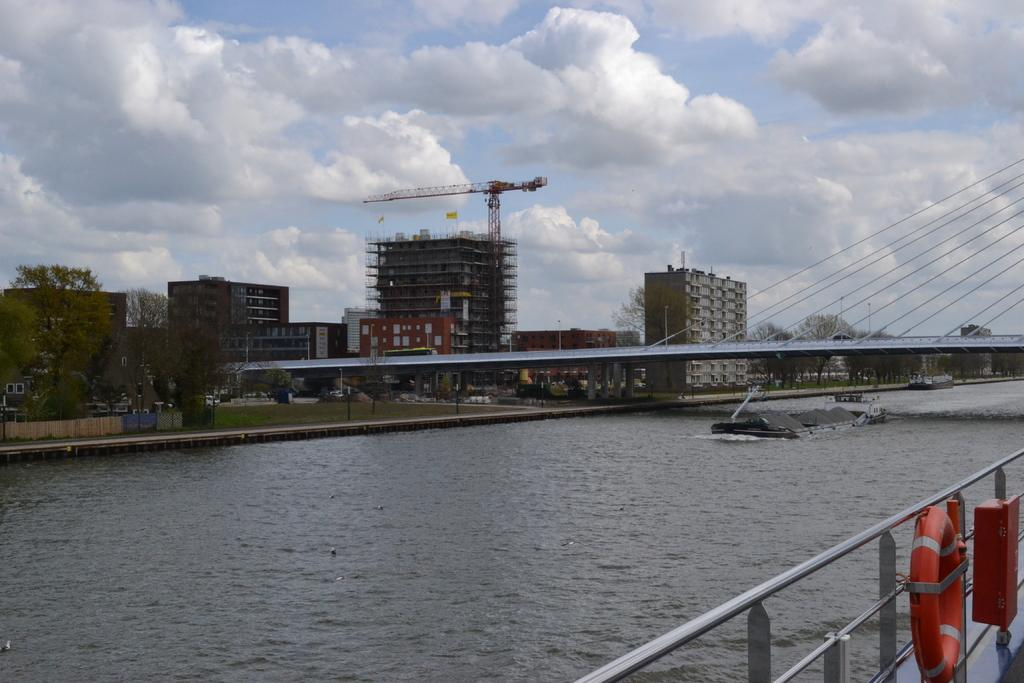What type of body of water is present in the image? There is a lake in the image. What structure can be seen on the lake? There is a bridge on the lake. Can you describe the background of the image? There is a bridge and buildings in the background of the image. How would you describe the sky in the image? The sky is clear in the image. What type of plate is being used to catch the fish in the image? There is no plate or fish present in the image; it features a lake, a bridge, and buildings in the background. 